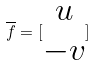<formula> <loc_0><loc_0><loc_500><loc_500>\overline { f } = [ \begin{matrix} u \\ - v \end{matrix} ]</formula> 